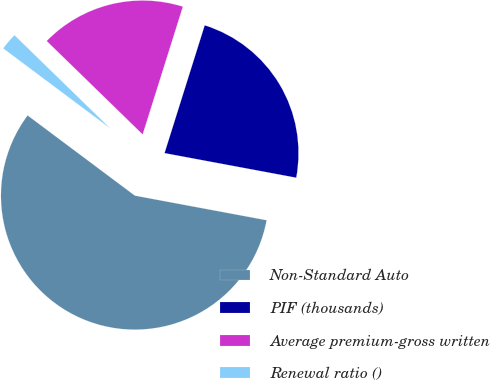Convert chart. <chart><loc_0><loc_0><loc_500><loc_500><pie_chart><fcel>Non-Standard Auto<fcel>PIF (thousands)<fcel>Average premium-gross written<fcel>Renewal ratio ()<nl><fcel>57.28%<fcel>23.09%<fcel>17.56%<fcel>2.07%<nl></chart> 